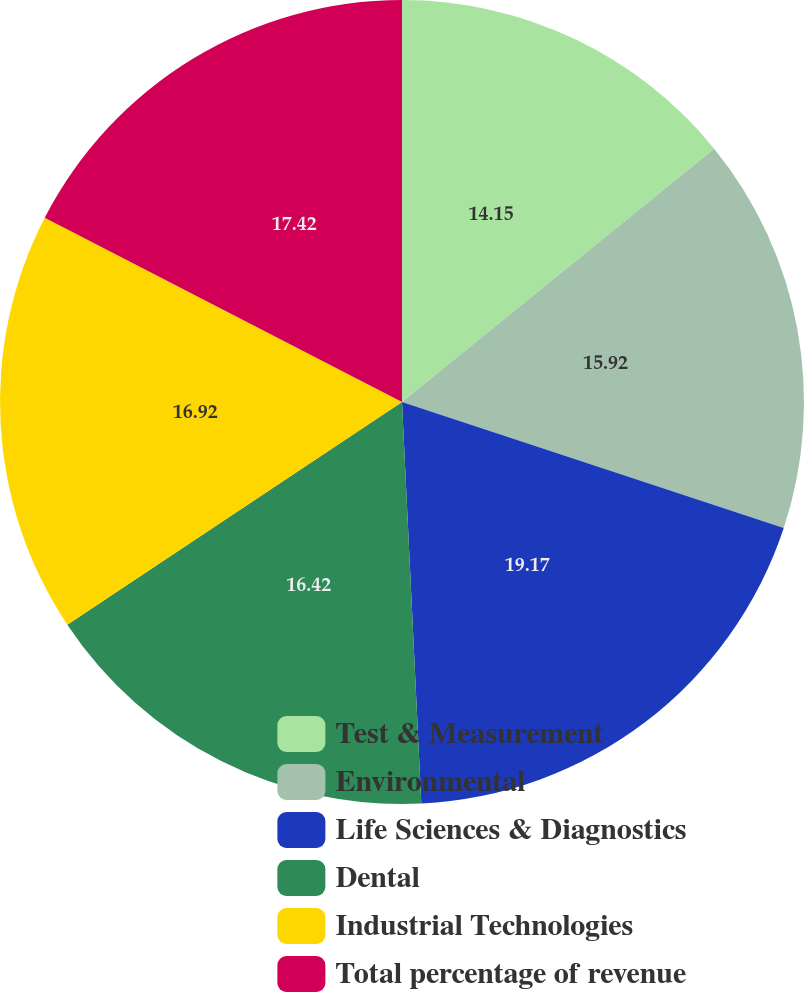Convert chart. <chart><loc_0><loc_0><loc_500><loc_500><pie_chart><fcel>Test & Measurement<fcel>Environmental<fcel>Life Sciences & Diagnostics<fcel>Dental<fcel>Industrial Technologies<fcel>Total percentage of revenue<nl><fcel>14.15%<fcel>15.92%<fcel>19.16%<fcel>16.42%<fcel>16.92%<fcel>17.42%<nl></chart> 